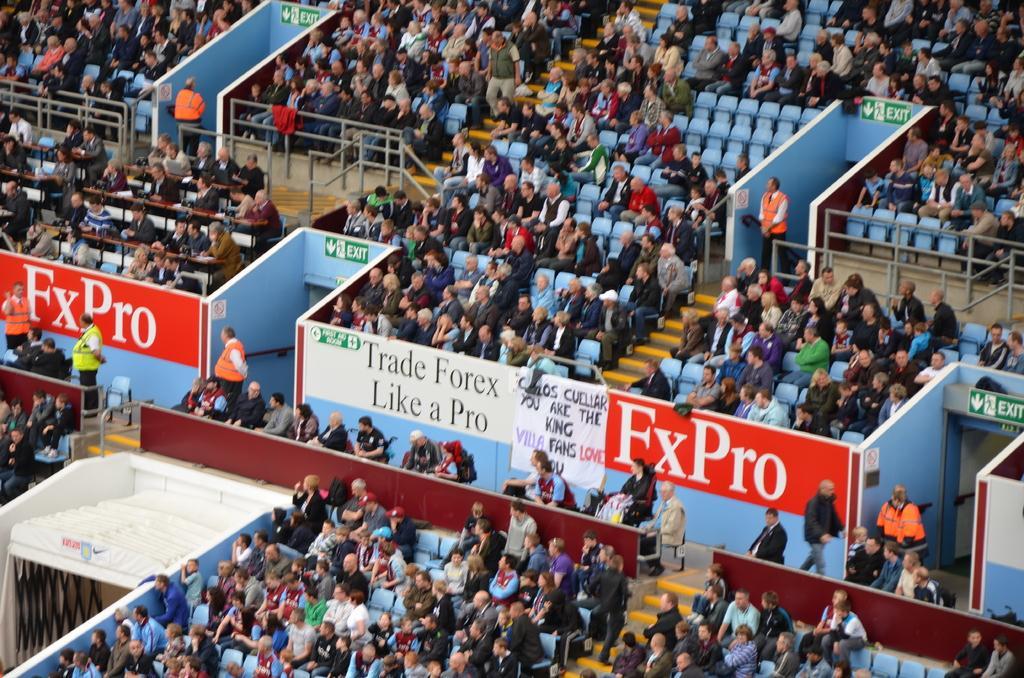How would you summarize this image in a sentence or two? The picture is taken in a stadium. In the picture there are people sitting in chairs. In the center of the picture there are hoardings and banner. The picture consists of ceiling and walls painted blue. 